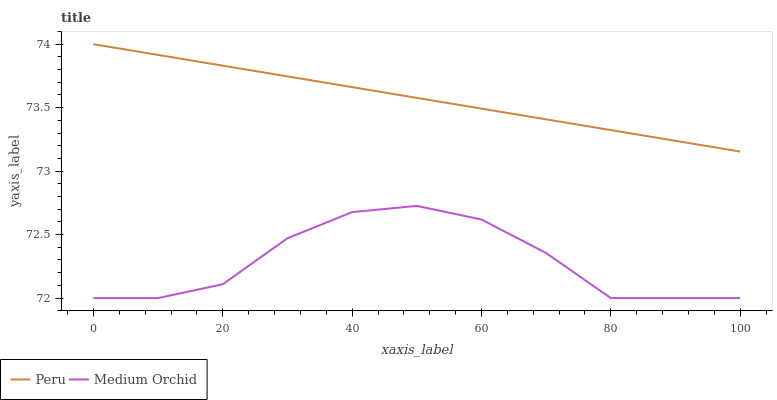Does Medium Orchid have the minimum area under the curve?
Answer yes or no. Yes. Does Peru have the maximum area under the curve?
Answer yes or no. Yes. Does Peru have the minimum area under the curve?
Answer yes or no. No. Is Peru the smoothest?
Answer yes or no. Yes. Is Medium Orchid the roughest?
Answer yes or no. Yes. Is Peru the roughest?
Answer yes or no. No. Does Medium Orchid have the lowest value?
Answer yes or no. Yes. Does Peru have the lowest value?
Answer yes or no. No. Does Peru have the highest value?
Answer yes or no. Yes. Is Medium Orchid less than Peru?
Answer yes or no. Yes. Is Peru greater than Medium Orchid?
Answer yes or no. Yes. Does Medium Orchid intersect Peru?
Answer yes or no. No. 